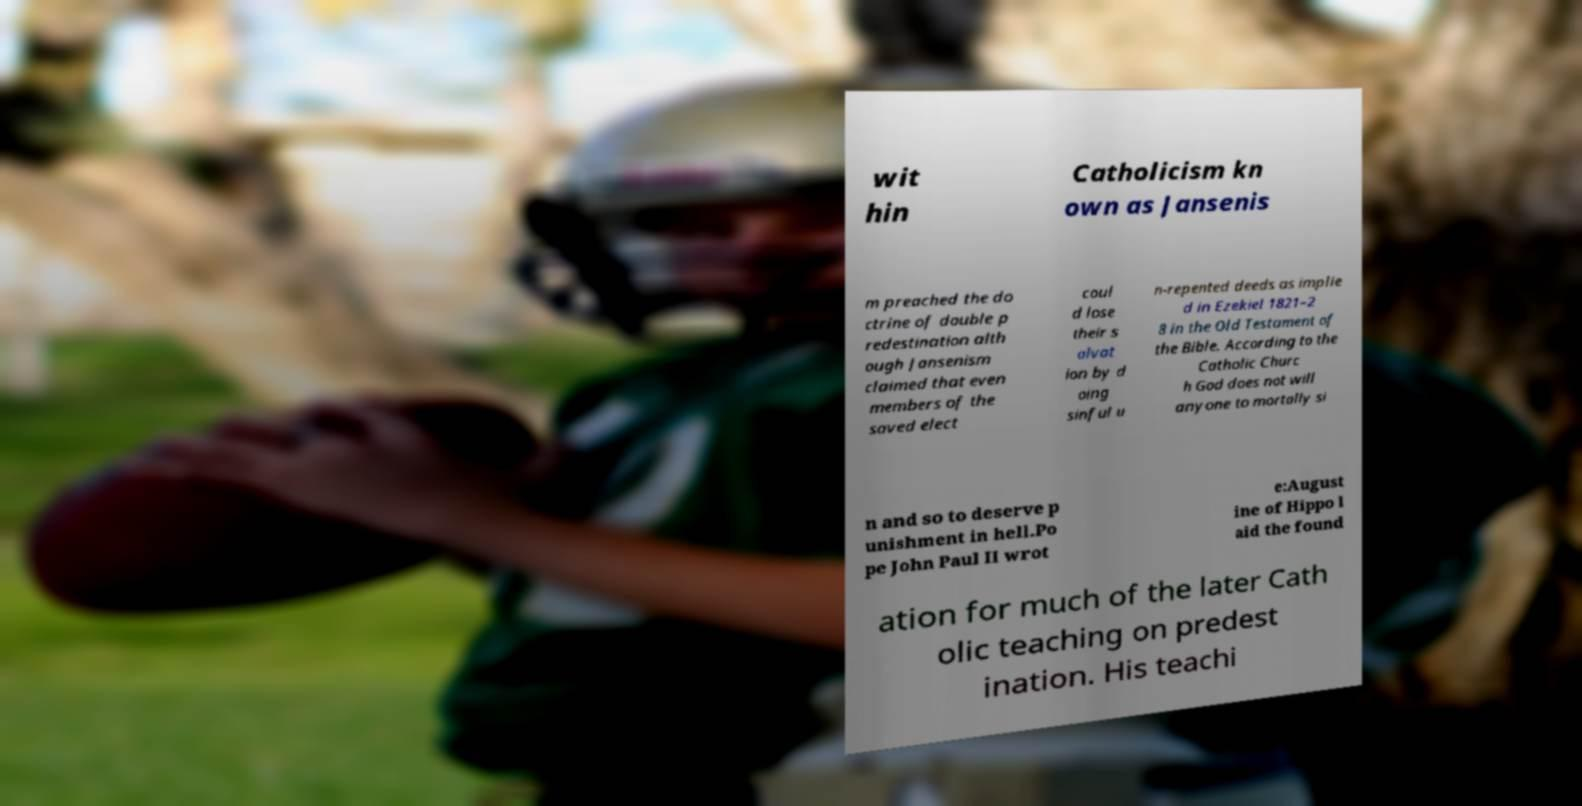Please identify and transcribe the text found in this image. wit hin Catholicism kn own as Jansenis m preached the do ctrine of double p redestination alth ough Jansenism claimed that even members of the saved elect coul d lose their s alvat ion by d oing sinful u n-repented deeds as implie d in Ezekiel 1821–2 8 in the Old Testament of the Bible. According to the Catholic Churc h God does not will anyone to mortally si n and so to deserve p unishment in hell.Po pe John Paul II wrot e:August ine of Hippo l aid the found ation for much of the later Cath olic teaching on predest ination. His teachi 